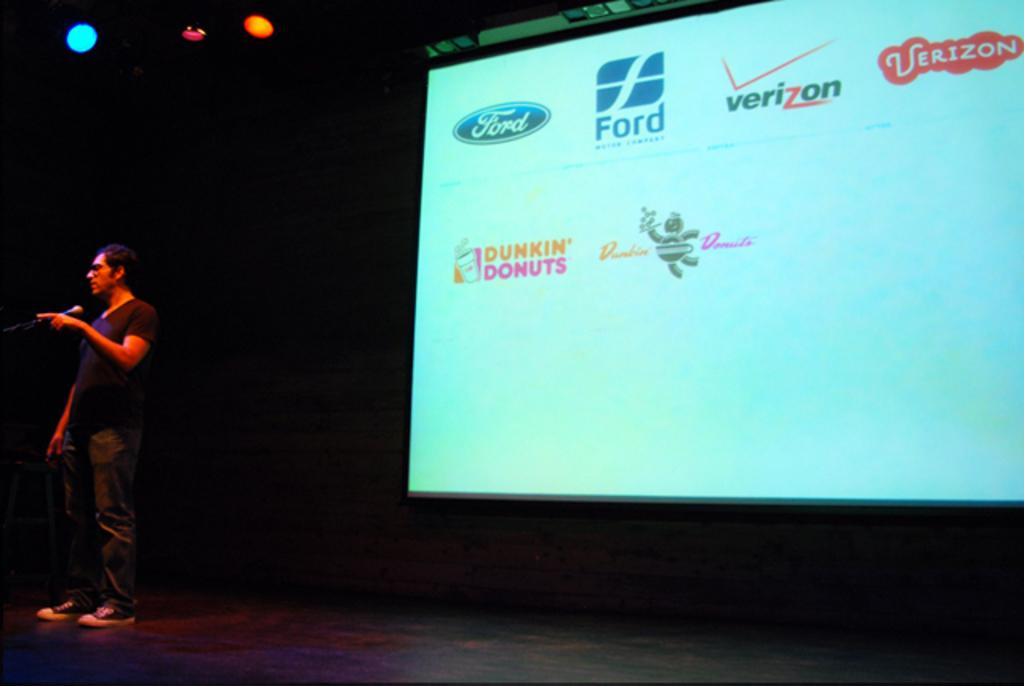<image>
Offer a succinct explanation of the picture presented. Two different logos for popular companies such as Ford and Dunkin Donuts appear on a screen. 